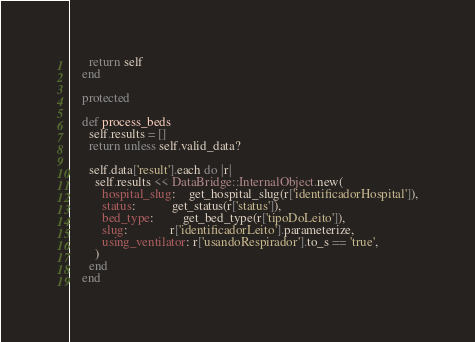<code> <loc_0><loc_0><loc_500><loc_500><_Ruby_>      return self
    end

    protected

    def process_beds
      self.results = []
      return unless self.valid_data?

      self.data['result'].each do |r|
        self.results << DataBridge::InternalObject.new(
          hospital_slug:    get_hospital_slug(r['identificadorHospital']),
          status:           get_status(r['status']),
          bed_type:         get_bed_type(r['tipoDoLeito']),
          slug:             r['identificadorLeito'].parameterize,
          using_ventilator: r['usandoRespirador'].to_s == 'true',
        )
      end
    end
</code> 